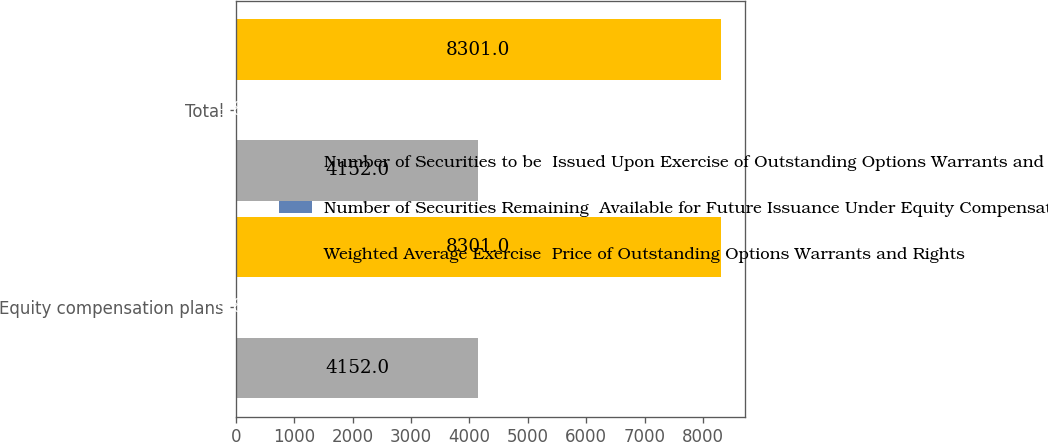Convert chart. <chart><loc_0><loc_0><loc_500><loc_500><stacked_bar_chart><ecel><fcel>Equity compensation plans<fcel>Total<nl><fcel>Number of Securities to be  Issued Upon Exercise of Outstanding Options Warrants and Rights<fcel>4152<fcel>4152<nl><fcel>Number of Securities Remaining  Available for Future Issuance Under Equity Compensation Plans excluding securities reflected in first column<fcel>9.87<fcel>9.87<nl><fcel>Weighted Average Exercise  Price of Outstanding Options Warrants and Rights<fcel>8301<fcel>8301<nl></chart> 